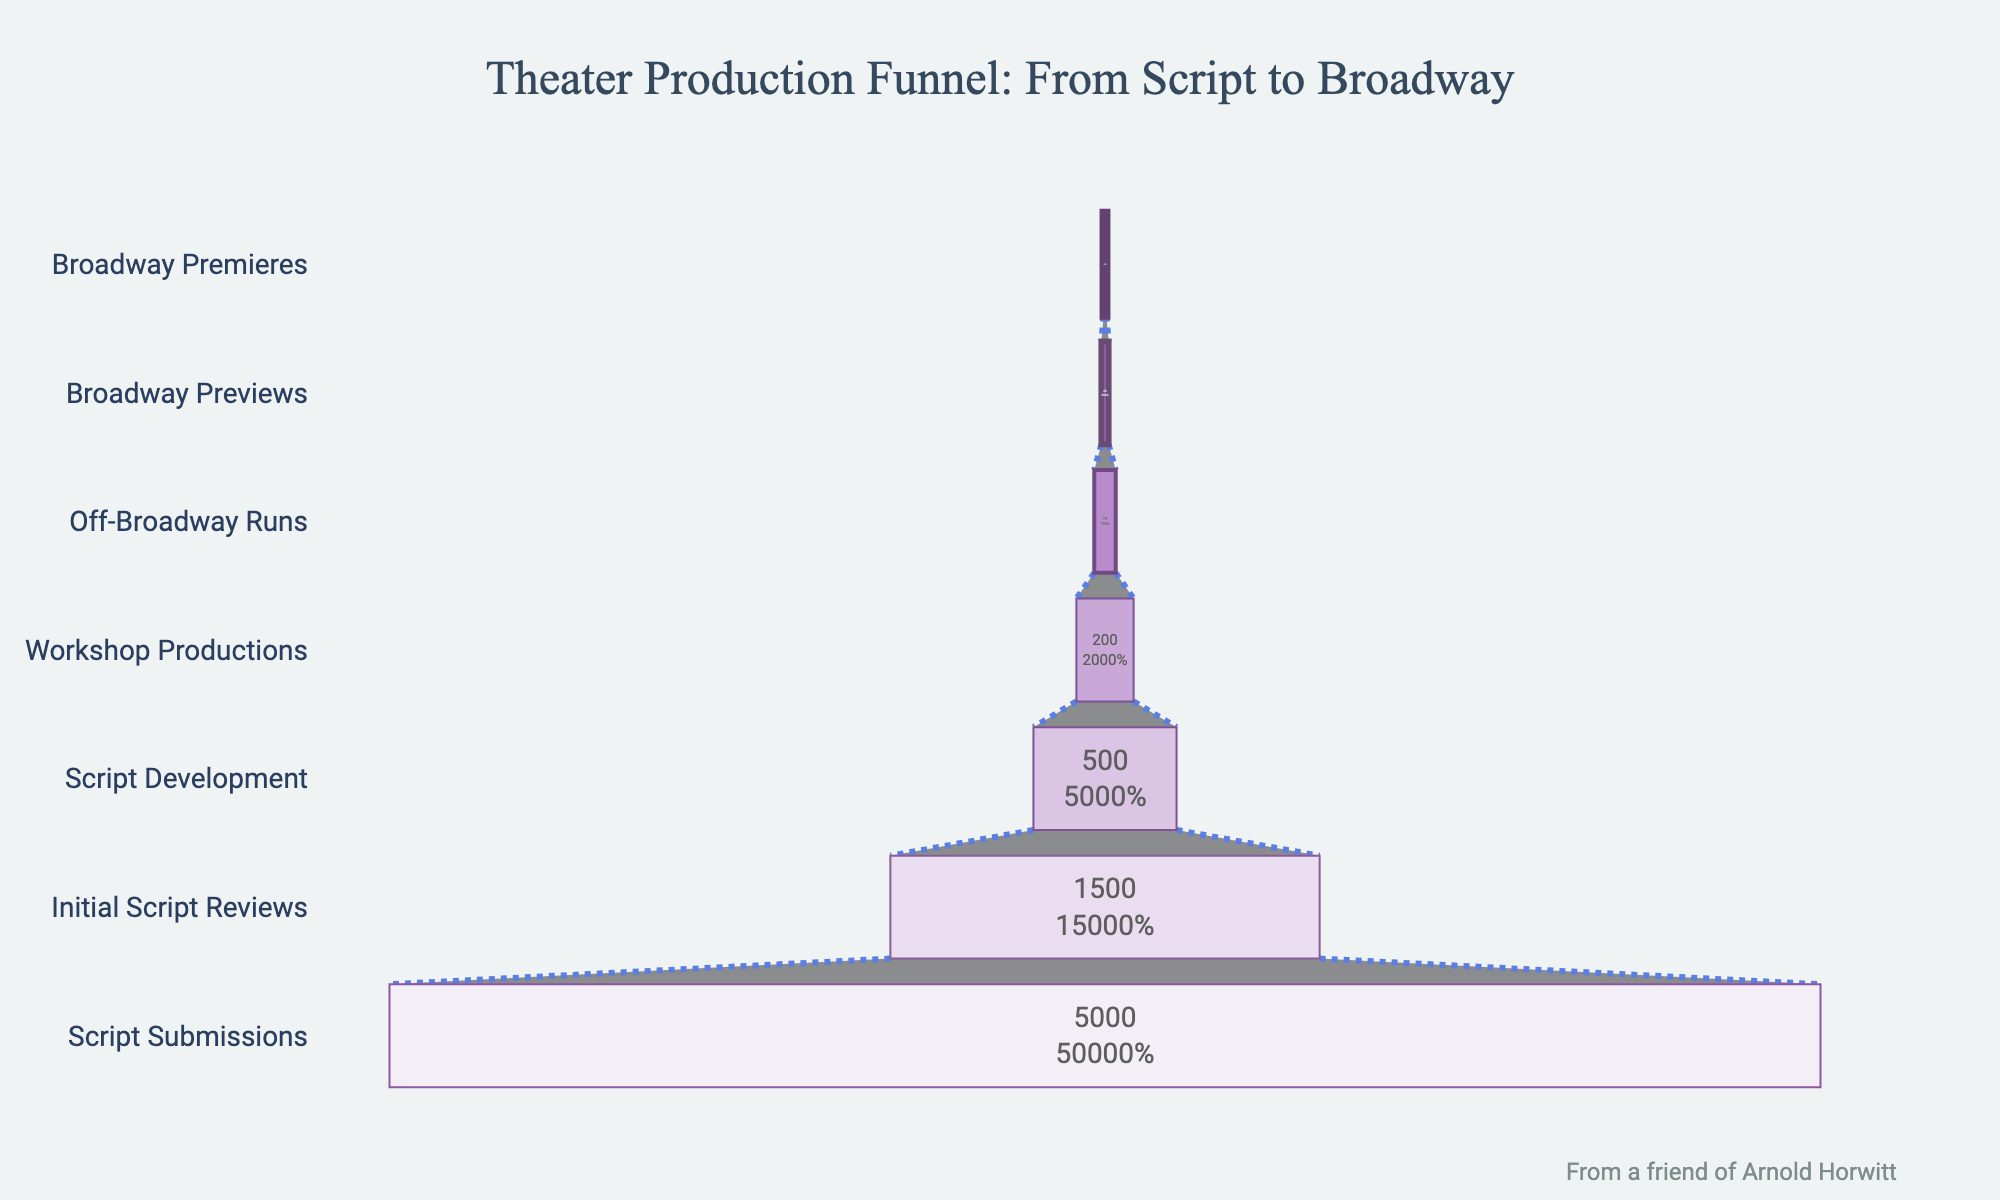How many scripts were submitted initially? Refer to the first stage in the funnel chart, "Script Submissions," and observe the corresponding number.
Answer: 5000 What's the percentage drop from Script Submissions to Initial Script Reviews? Subtract the number of "Initial Script Reviews" (1500) from "Script Submissions" (5000), and then divide by "Script Submissions" (5000), multiplying by 100 to get the percentage. Calculation: ((5000 - 1500) / 5000) * 100 = 70%
Answer: 70% How many scripts made it through to Script Development? Locate the stage labeled "Script Development" on the funnel chart and note the corresponding number.
Answer: 500 Compare the number of scripts in the Script Development stage with those in the Workshop Productions stage. Which stage has more scripts, and by how many? Identify the numbers for "Script Development" (500) and "Workshop Productions" (200). Subtract the smaller number (200) from the larger number (500) to find the difference. 500 - 200 = 300
Answer: Script Development has 300 more scripts What is the overall conversion rate from Script Submissions to Broadway Premieres? Divide the number of "Broadway Premieres" (10) by "Script Submissions" (5000), and multiply by 100 to get the percentage. Calculation: (10 / 5000) * 100 = 0.2%
Answer: 0.2% Which stage has the smallest number of scripts and what is that number? Find the stage with the smallest bar/number in the funnel chart, which is "Broadway Premieres," and note the number.
Answer: 10 How many scripts reach the Off-Broadway Runs stage? Locate the stage labeled "Off-Broadway Runs" in the funnel chart and note the corresponding number.
Answer: 75 What is the difference in the number of scripts between Off-Broadway Runs and Broadway Previews? Identify the numbers for "Off-Broadway Runs" (75) and "Broadway Previews" (25). Subtract the number of "Broadway Previews" (25) from "Off-Broadway Runs" (75). 75 - 25 = 50
Answer: 50 How many stages are there from Script Submissions to Broadway Premieres, and what are they? Count the total stages listed in the funnel chart and list their names.
Answer: 7 stages: Script Submissions, Initial Script Reviews, Script Development, Workshop Productions, Off-Broadway Runs, Broadway Previews, Broadway Premieres 